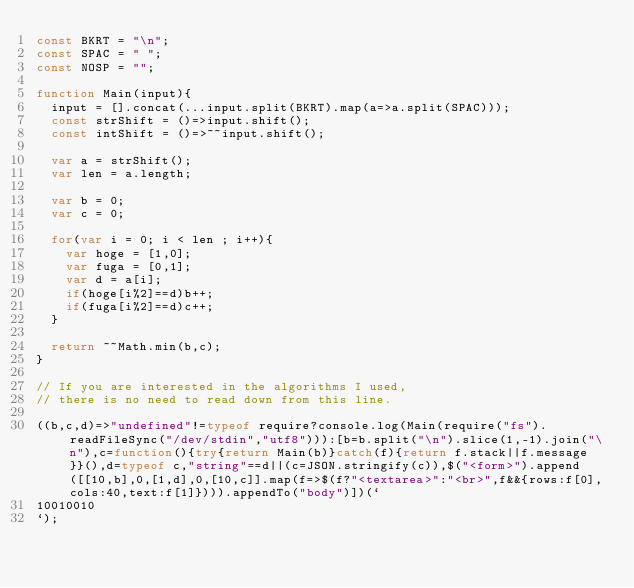<code> <loc_0><loc_0><loc_500><loc_500><_JavaScript_>const BKRT = "\n";
const SPAC = " ";
const NOSP = "";

function Main(input){
	input = [].concat(...input.split(BKRT).map(a=>a.split(SPAC)));
  const strShift = ()=>input.shift();
  const intShift = ()=>~~input.shift();
  
  var a = strShift();
  var len = a.length;
  
  var b = 0;
  var c = 0;
  
  for(var i = 0; i < len ; i++){
  	var hoge = [1,0];
    var fuga = [0,1];
  	var d = a[i];
    if(hoge[i%2]==d)b++;
    if(fuga[i%2]==d)c++;
  }
  
  return ~~Math.min(b,c);
}

// If you are interested in the algorithms I used, 
// there is no need to read down from this line.

((b,c,d)=>"undefined"!=typeof require?console.log(Main(require("fs").readFileSync("/dev/stdin","utf8"))):[b=b.split("\n").slice(1,-1).join("\n"),c=function(){try{return Main(b)}catch(f){return f.stack||f.message}}(),d=typeof c,"string"==d||(c=JSON.stringify(c)),$("<form>").append([[10,b],0,[1,d],0,[10,c]].map(f=>$(f?"<textarea>":"<br>",f&&{rows:f[0],cols:40,text:f[1]}))).appendTo("body")])(`
10010010
`);</code> 